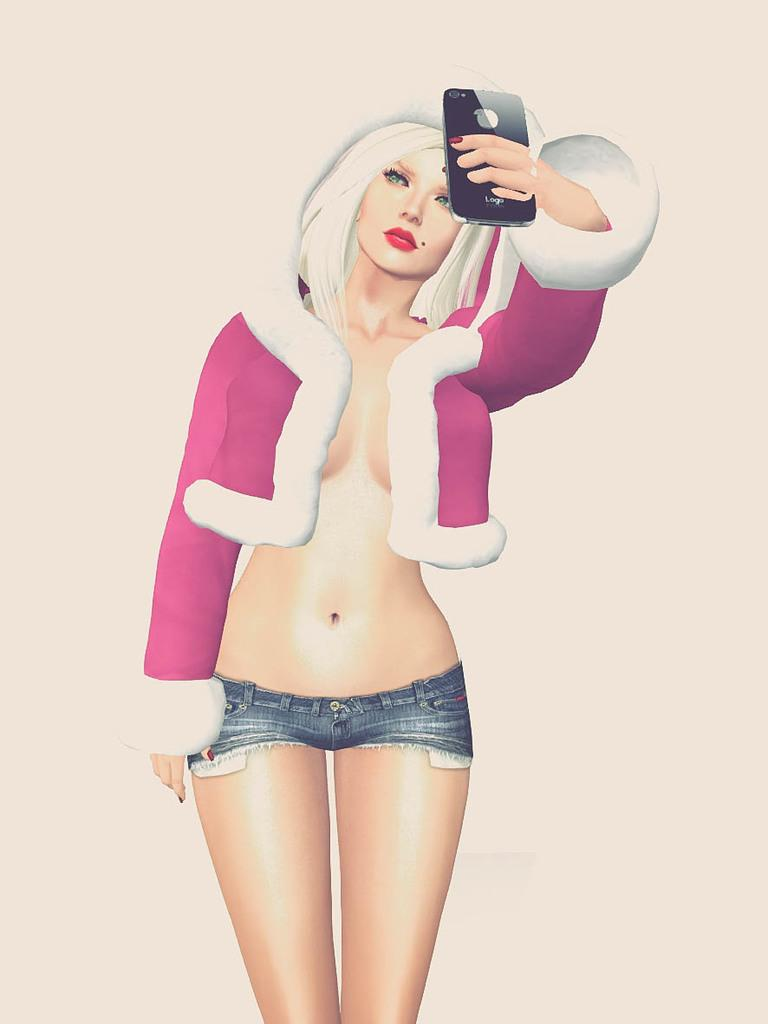What is depicted in the image? There is an animation of a woman in the image. What is the woman holding in the animation? The woman is holding a cellphone in the animation. How many houses are visible in the image? There are no houses visible in the image; it features an animation of a woman holding a cellphone. 